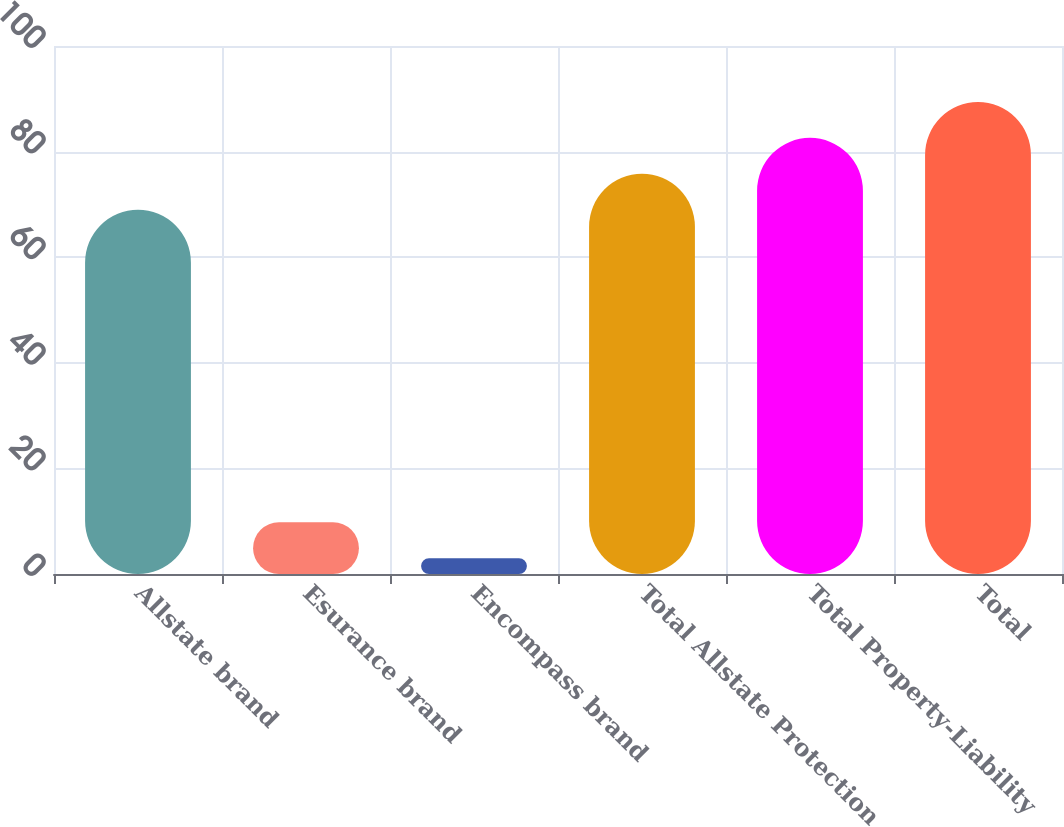Convert chart to OTSL. <chart><loc_0><loc_0><loc_500><loc_500><bar_chart><fcel>Allstate brand<fcel>Esurance brand<fcel>Encompass brand<fcel>Total Allstate Protection<fcel>Total Property-Liability<fcel>Total<nl><fcel>69<fcel>9.8<fcel>3<fcel>75.8<fcel>82.6<fcel>89.4<nl></chart> 